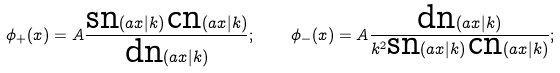<formula> <loc_0><loc_0><loc_500><loc_500>\phi _ { + } ( x ) = A \frac { \text {sn} ( a x | k ) \, \text {cn} ( a x | k ) } { \text {dn} ( a x | k ) } ; \quad \phi _ { - } ( x ) = A \frac { \text {dn} ( a x | k ) } { k ^ { 2 } \text {sn} ( a x | k ) \, \text {cn} ( a x | k ) } ;</formula> 